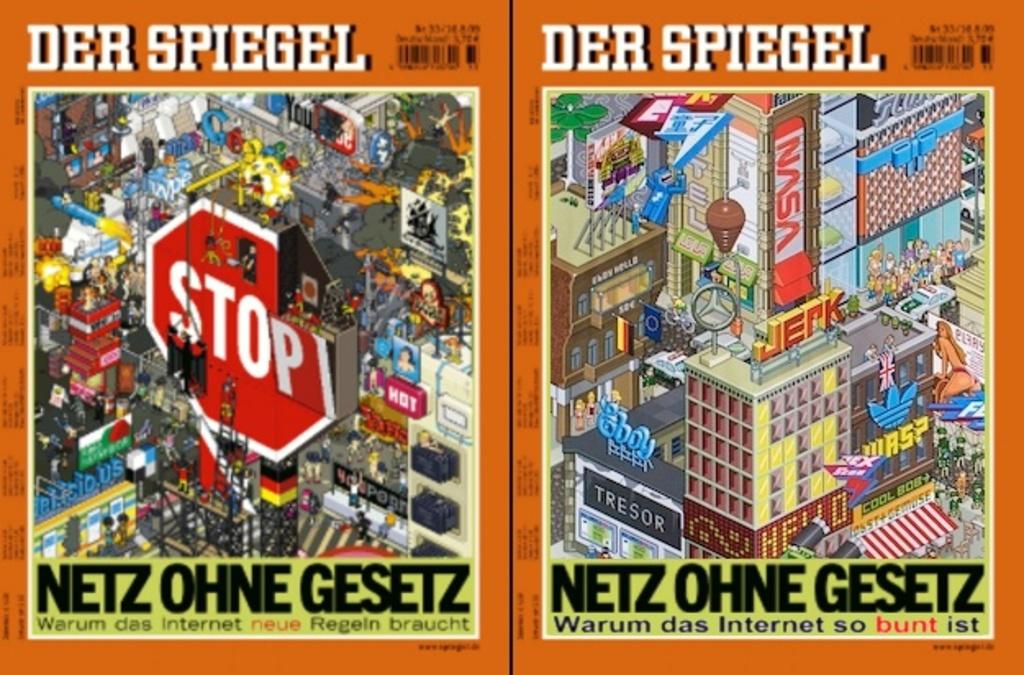What word is in red at the bottom of the right image?
Provide a short and direct response. Bunt. What is the name of the magazine?
Make the answer very short. Der spiegel. 